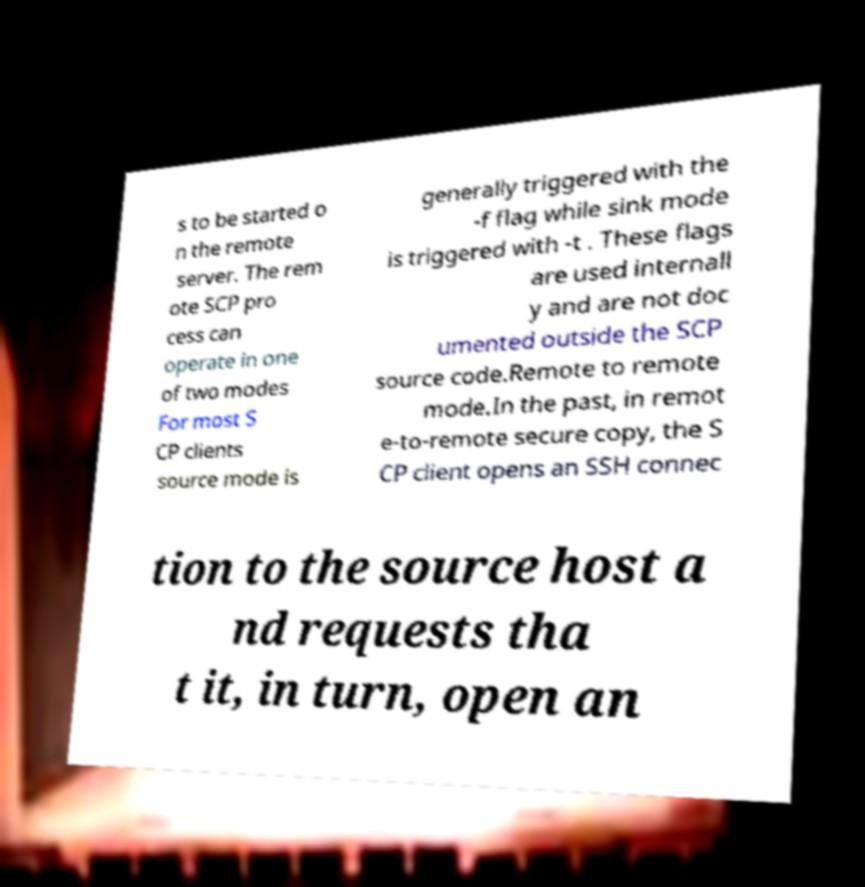There's text embedded in this image that I need extracted. Can you transcribe it verbatim? s to be started o n the remote server. The rem ote SCP pro cess can operate in one of two modes For most S CP clients source mode is generally triggered with the -f flag while sink mode is triggered with -t . These flags are used internall y and are not doc umented outside the SCP source code.Remote to remote mode.In the past, in remot e-to-remote secure copy, the S CP client opens an SSH connec tion to the source host a nd requests tha t it, in turn, open an 